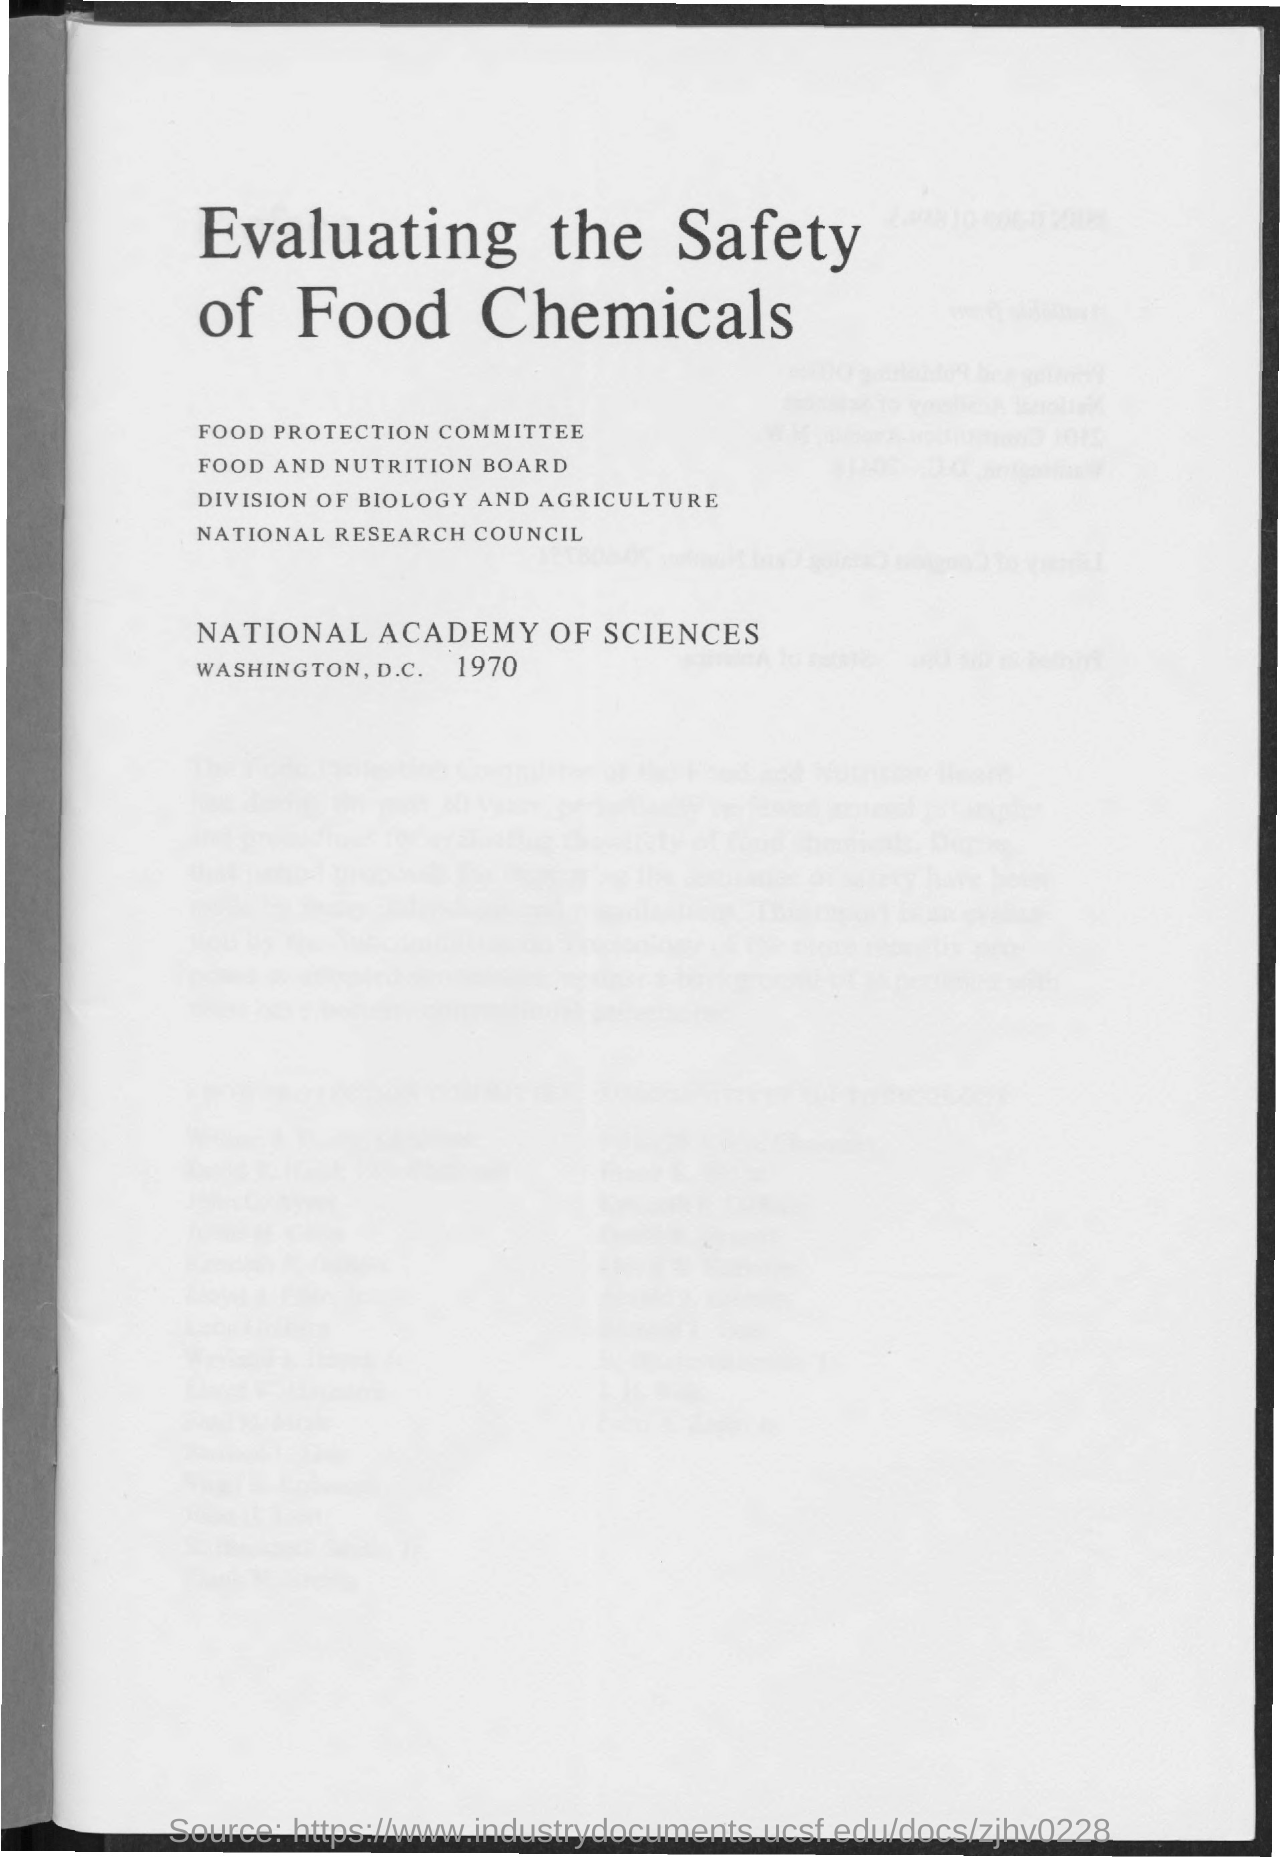Point out several critical features in this image. The year mentioned in the document is 1970. The title of the document is 'Evaluating the Safety of Food Chemicals'. 